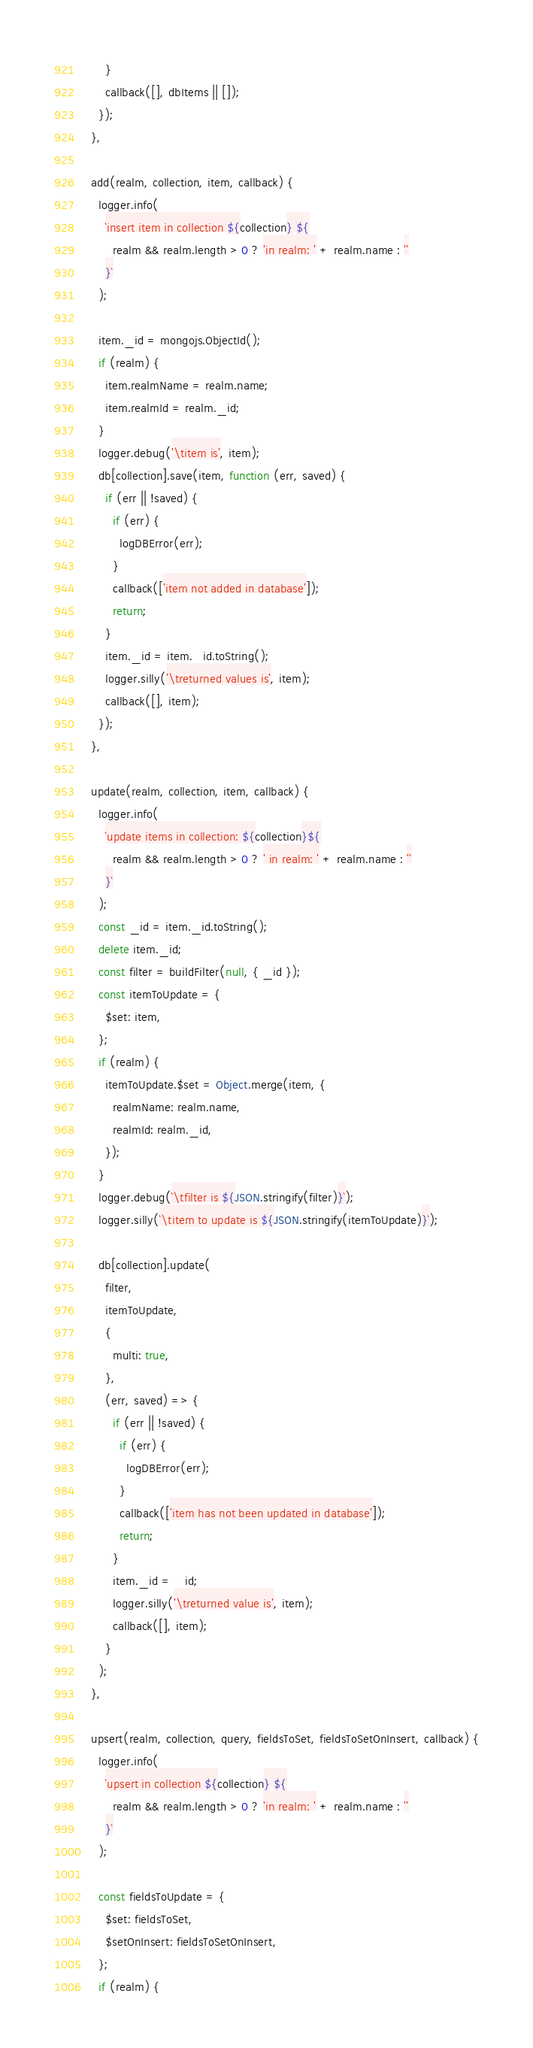<code> <loc_0><loc_0><loc_500><loc_500><_JavaScript_>      }
      callback([], dbItems || []);
    });
  },

  add(realm, collection, item, callback) {
    logger.info(
      `insert item in collection ${collection} ${
        realm && realm.length > 0 ? 'in realm: ' + realm.name : ''
      }`
    );

    item._id = mongojs.ObjectId();
    if (realm) {
      item.realmName = realm.name;
      item.realmId = realm._id;
    }
    logger.debug('\titem is', item);
    db[collection].save(item, function (err, saved) {
      if (err || !saved) {
        if (err) {
          logDBError(err);
        }
        callback(['item not added in database']);
        return;
      }
      item._id = item._id.toString();
      logger.silly('\treturned values is', item);
      callback([], item);
    });
  },

  update(realm, collection, item, callback) {
    logger.info(
      `update items in collection: ${collection}${
        realm && realm.length > 0 ? ' in realm: ' + realm.name : ''
      }`
    );
    const _id = item._id.toString();
    delete item._id;
    const filter = buildFilter(null, { _id });
    const itemToUpdate = {
      $set: item,
    };
    if (realm) {
      itemToUpdate.$set = Object.merge(item, {
        realmName: realm.name,
        realmId: realm._id,
      });
    }
    logger.debug(`\tfilter is ${JSON.stringify(filter)}`);
    logger.silly(`\titem to update is ${JSON.stringify(itemToUpdate)}`);

    db[collection].update(
      filter,
      itemToUpdate,
      {
        multi: true,
      },
      (err, saved) => {
        if (err || !saved) {
          if (err) {
            logDBError(err);
          }
          callback(['item has not been updated in database']);
          return;
        }
        item._id = _id;
        logger.silly('\treturned value is', item);
        callback([], item);
      }
    );
  },

  upsert(realm, collection, query, fieldsToSet, fieldsToSetOnInsert, callback) {
    logger.info(
      `upsert in collection ${collection} ${
        realm && realm.length > 0 ? 'in realm: ' + realm.name : ''
      }`
    );

    const fieldsToUpdate = {
      $set: fieldsToSet,
      $setOnInsert: fieldsToSetOnInsert,
    };
    if (realm) {</code> 